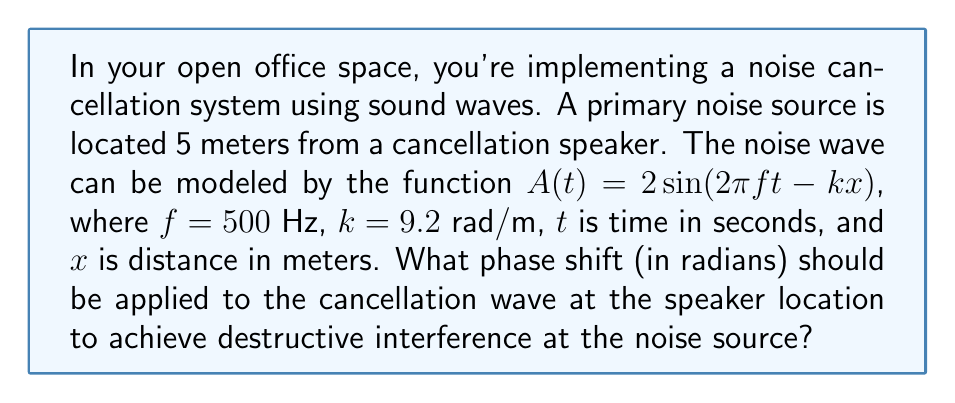Give your solution to this math problem. To solve this problem, we need to understand the principles of wave interference and phase shifts. Let's break it down step-by-step:

1) The given wave equation is $A(t) = 2\sin(2\pi ft - kx)$, where:
   $f = 500$ Hz (frequency)
   $k = 9.2$ rad/m (wave number)
   $x = 5$ m (distance from noise source to cancellation speaker)

2) To achieve destructive interference, the cancellation wave should be 180° (or $\pi$ radians) out of phase with the noise wave at the source location.

3) The phase of the noise wave at the source (x = 0) is:
   $\phi_{source} = 2\pi ft$

4) The phase of the noise wave at the speaker location (x = 5) is:
   $\phi_{speaker} = 2\pi ft - kx = 2\pi ft - 9.2 \cdot 5 = 2\pi ft - 46$ rad

5) For the cancellation wave to be $\pi$ radians out of phase at the source, its phase at the speaker should be:
   $\phi_{cancellation} = 2\pi ft - 46 - \pi$ rad

6) The required phase shift is the difference between the cancellation wave phase and the original wave phase at the speaker:

   $$\Delta\phi = \phi_{cancellation} - \phi_{speaker} = (2\pi ft - 46 - \pi) - (2\pi ft - 46) = -\pi$$ rad

Therefore, the cancellation wave should be shifted by $-\pi$ radians (or $-180°$) at the speaker location.
Answer: $-\pi$ radians 